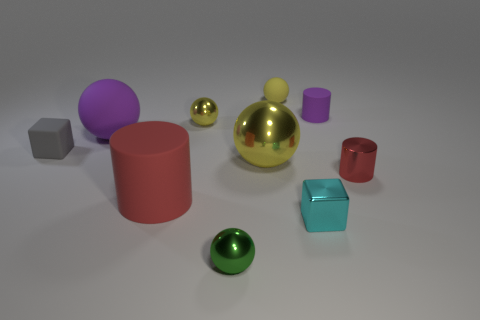Do the matte cylinder to the right of the cyan metal block and the matte ball in front of the tiny matte cylinder have the same color?
Offer a very short reply. Yes. How many cyan shiny things are the same shape as the tiny yellow rubber object?
Offer a terse response. 0. Are there the same number of red things that are right of the tiny shiny block and tiny gray things in front of the small yellow metal sphere?
Offer a very short reply. Yes. Are any green cylinders visible?
Keep it short and to the point. No. There is a rubber cylinder in front of the small cube left of the block on the right side of the small gray block; what is its size?
Keep it short and to the point. Large. There is a purple thing that is the same size as the green shiny object; what is its shape?
Your answer should be compact. Cylinder. What number of objects are either matte cylinders in front of the small red object or gray things?
Your answer should be compact. 2. Are there any tiny purple matte objects behind the matte cylinder that is left of the tiny object behind the purple rubber cylinder?
Make the answer very short. Yes. How many tiny purple things are there?
Offer a terse response. 1. What number of things are either tiny blocks on the right side of the green metallic ball or metal things left of the small cyan cube?
Offer a very short reply. 4. 